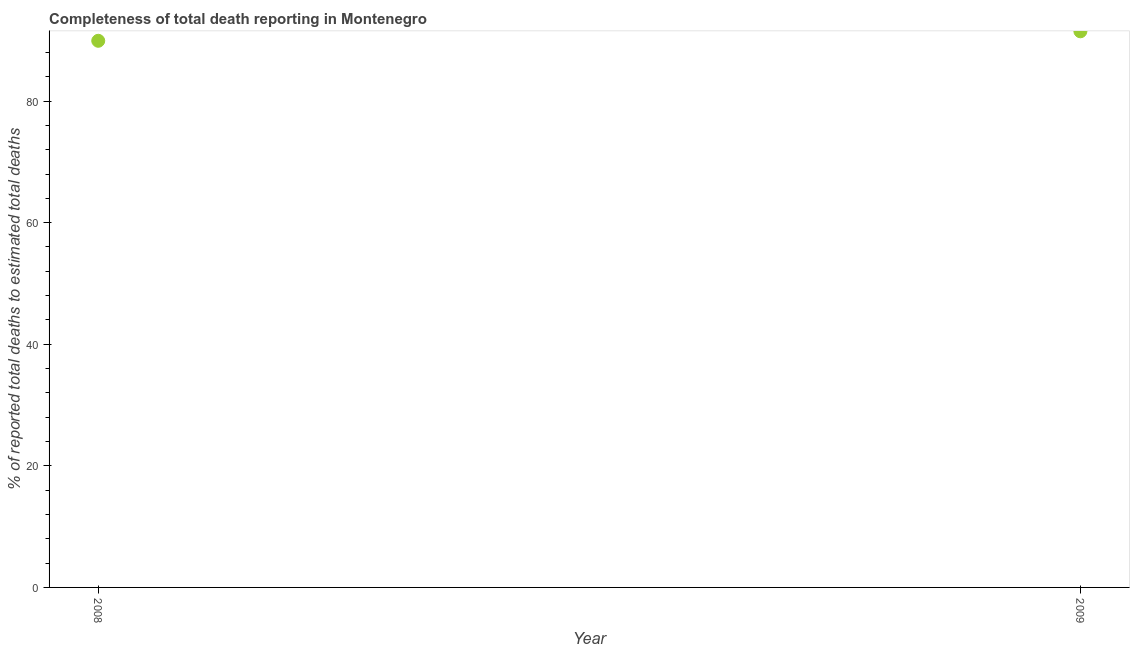What is the completeness of total death reports in 2009?
Ensure brevity in your answer.  91.48. Across all years, what is the maximum completeness of total death reports?
Offer a very short reply. 91.48. Across all years, what is the minimum completeness of total death reports?
Your response must be concise. 89.92. In which year was the completeness of total death reports minimum?
Keep it short and to the point. 2008. What is the sum of the completeness of total death reports?
Make the answer very short. 181.4. What is the difference between the completeness of total death reports in 2008 and 2009?
Keep it short and to the point. -1.56. What is the average completeness of total death reports per year?
Ensure brevity in your answer.  90.7. What is the median completeness of total death reports?
Keep it short and to the point. 90.7. What is the ratio of the completeness of total death reports in 2008 to that in 2009?
Provide a short and direct response. 0.98. Does the completeness of total death reports monotonically increase over the years?
Your response must be concise. Yes. How many dotlines are there?
Provide a succinct answer. 1. How many years are there in the graph?
Provide a succinct answer. 2. Does the graph contain any zero values?
Ensure brevity in your answer.  No. Does the graph contain grids?
Ensure brevity in your answer.  No. What is the title of the graph?
Give a very brief answer. Completeness of total death reporting in Montenegro. What is the label or title of the Y-axis?
Provide a short and direct response. % of reported total deaths to estimated total deaths. What is the % of reported total deaths to estimated total deaths in 2008?
Ensure brevity in your answer.  89.92. What is the % of reported total deaths to estimated total deaths in 2009?
Offer a very short reply. 91.48. What is the difference between the % of reported total deaths to estimated total deaths in 2008 and 2009?
Your response must be concise. -1.56. What is the ratio of the % of reported total deaths to estimated total deaths in 2008 to that in 2009?
Give a very brief answer. 0.98. 